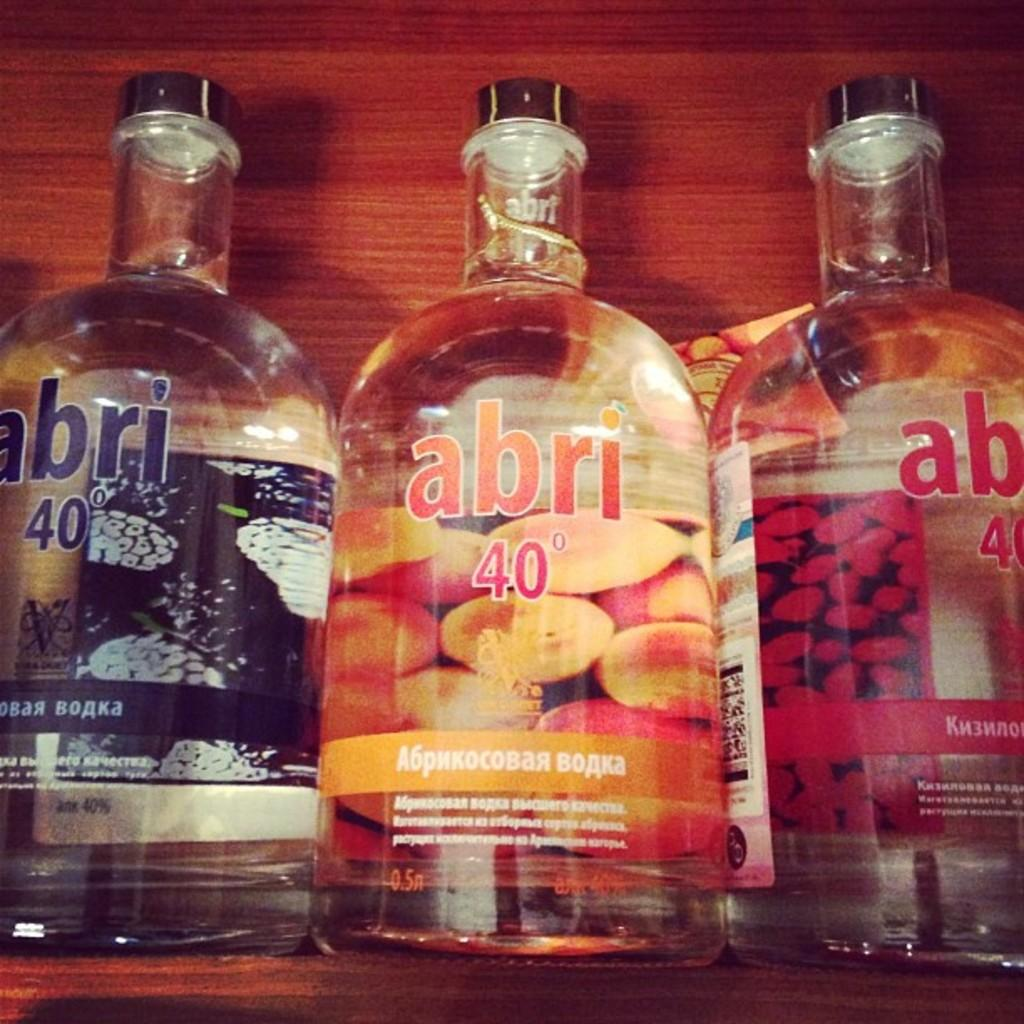How many bottles are visible in the image? There are three bottles in the image. Where are the bottles located? The bottles are inside a rack. What feature do the bottles have in common? The bottles have caps. What is inside the bottles? The bottles are filled with liquids. What type of scarf is wrapped around the bottles in the image? There is no scarf present in the image; the bottles are inside a rack with caps. Can you hear a bell ringing in the image? There is no bell present in the image, so it cannot be heard. 